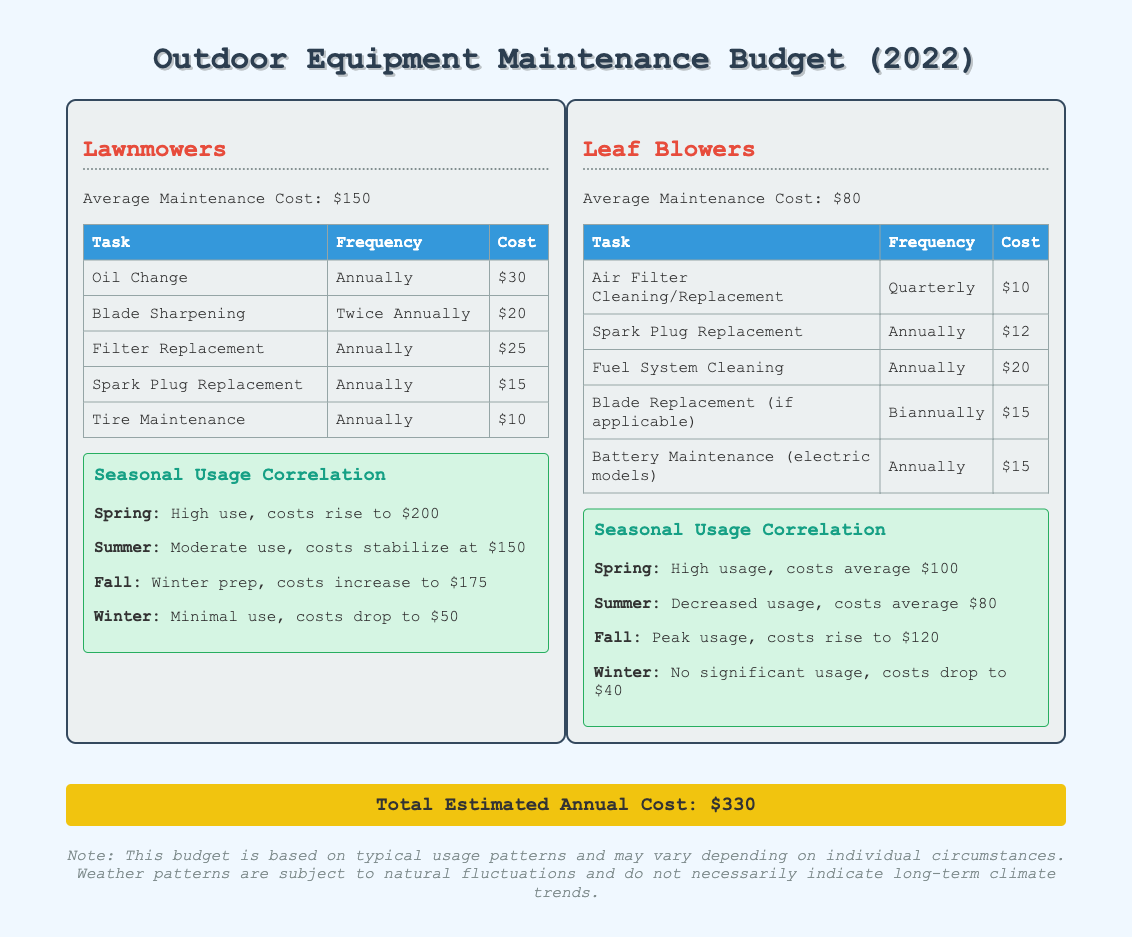what is the average maintenance cost for lawnmowers? The average maintenance cost for lawnmowers is mentioned in the document as $150.
Answer: $150 how often is the air filter cleaned or replaced for leaf blowers? The document specifies that the air filter is cleaned or replaced quarterly for leaf blowers.
Answer: Quarterly what is the total estimated annual cost for outdoor equipment maintenance? The total estimated annual cost is provided at the bottom of the document as $330.
Answer: $330 what task for lawnmowers has the highest frequency? The task with the highest frequency for lawnmowers is blade sharpening, which occurs twice annually.
Answer: Twice Annually in which season do lawnmowers have minimal usage? The document states that lawnmowers have minimal usage in winter.
Answer: Winter which outdoor equipment has an average maintenance cost of $80? The document indicates that leaf blowers have an average maintenance cost of $80.
Answer: Leaf Blowers during which season does the cost of maintenance for leaf blowers increase to $120? The document mentions that during fall, the costs for leaf blowers rise to $120.
Answer: Fall how much does tire maintenance cost for lawnmowers? The document lists the cost of tire maintenance for lawnmowers as $10.
Answer: $10 what maintenance task is performed annually for leaf blowers? According to the document, spark plug replacement is performed annually for leaf blowers.
Answer: Spark Plug Replacement 